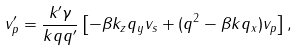<formula> <loc_0><loc_0><loc_500><loc_500>v _ { p } ^ { \prime } = \frac { k ^ { \prime } \gamma } { k q q ^ { \prime } } \left [ - \beta k _ { z } q _ { y } v _ { s } + ( q ^ { 2 } - \beta k q _ { x } ) v _ { p } \right ] ,</formula> 